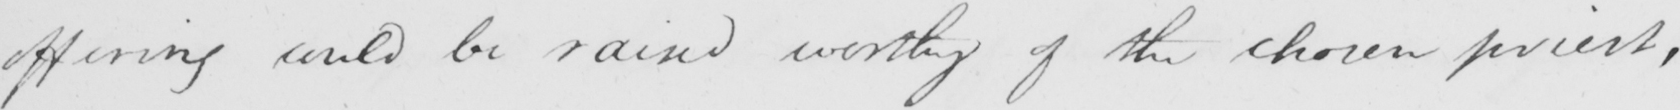What does this handwritten line say? offering could be raind worthy of the chosen priest , 